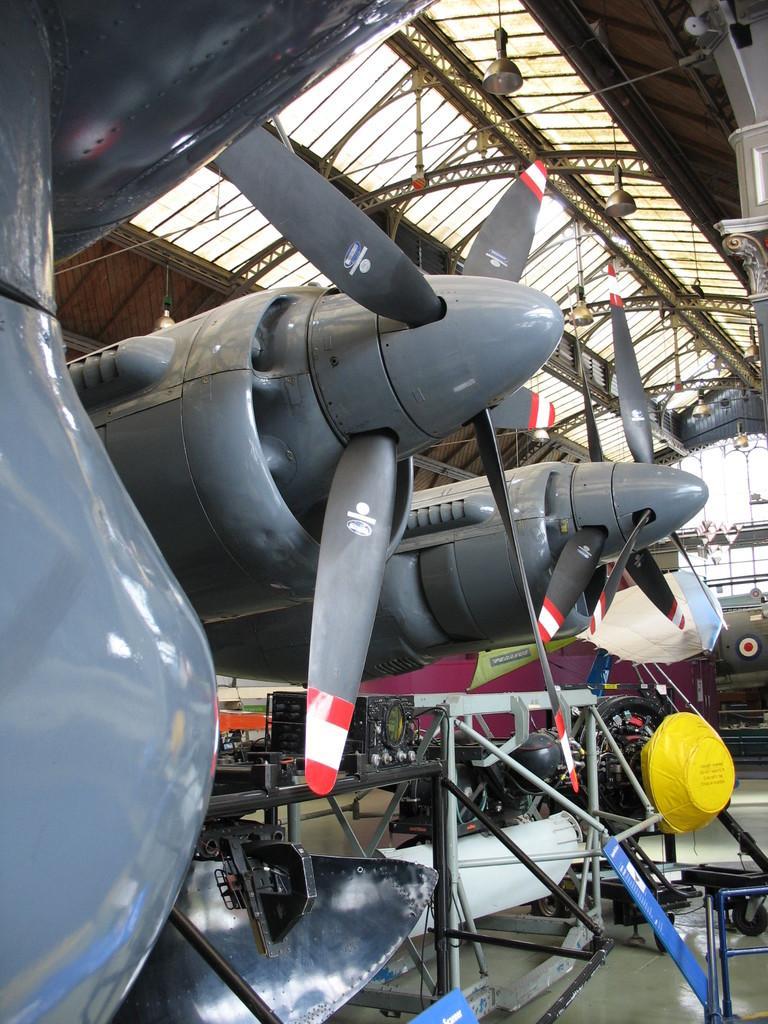Please provide a concise description of this image. Here in this picture we can see number of aircrafts present on the floor over there and in the middle we can see fans of it and on the top we can see a shed which is covered all over there and we can see lights on the roof over there. 